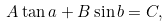Convert formula to latex. <formula><loc_0><loc_0><loc_500><loc_500>A \tan a + B \sin b = C ,</formula> 